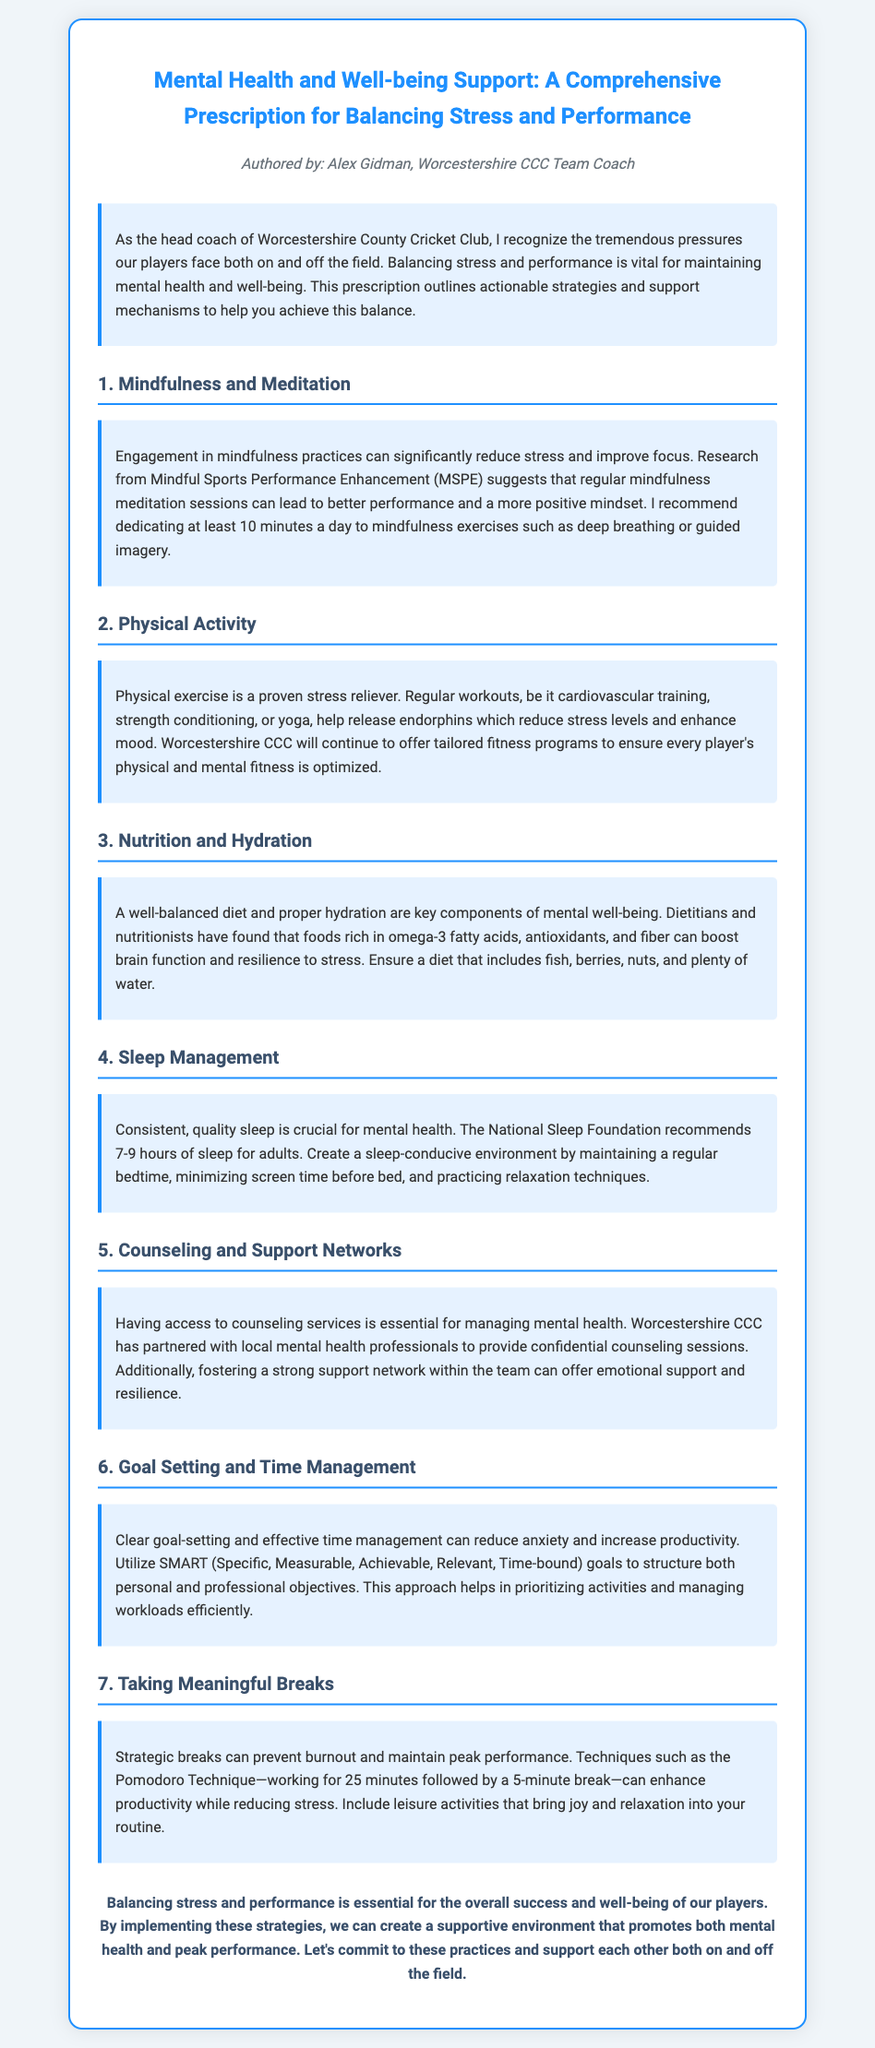What is the title of the document? The title of the document is provided at the beginning and is "Mental Health and Well-being Support: A Comprehensive Prescription for Balancing Stress and Performance."
Answer: Mental Health and Well-being Support: A Comprehensive Prescription for Balancing Stress and Performance Who authored the document? The author of the document is mentioned in the author section, which states that it is authored by Alex Gidman.
Answer: Alex Gidman What is the minimum recommended time for mindfulness exercises? The document advises dedicating at least 10 minutes a day to mindfulness exercises such as deep breathing or guided imagery.
Answer: 10 minutes What is one key component of mental well-being mentioned? The document highlights that a well-balanced diet and proper hydration are key components of mental well-being.
Answer: A well-balanced diet and proper hydration How many hours of sleep does the National Sleep Foundation recommend for adults? The recommendation from the National Sleep Foundation is explicitly stated as 7-9 hours of sleep for adults.
Answer: 7-9 hours What technique is suggested for taking meaningful breaks? The document mentions the Pomodoro Technique as a suggested method for taking meaningful breaks.
Answer: Pomodoro Technique What type of goals should be utilized according to the document? The document recommends using SMART goals to structure both personal and professional objectives.
Answer: SMART goals Which practice can enhance productivity while reducing stress? The practice of taking strategic breaks, specifically using techniques like the Pomodoro Technique, is highlighted to enhance productivity while reducing stress.
Answer: Taking strategic breaks What do counseling services provide according to the document? The document states that having access to counseling services is essential for managing mental health.
Answer: Essential for managing mental health 